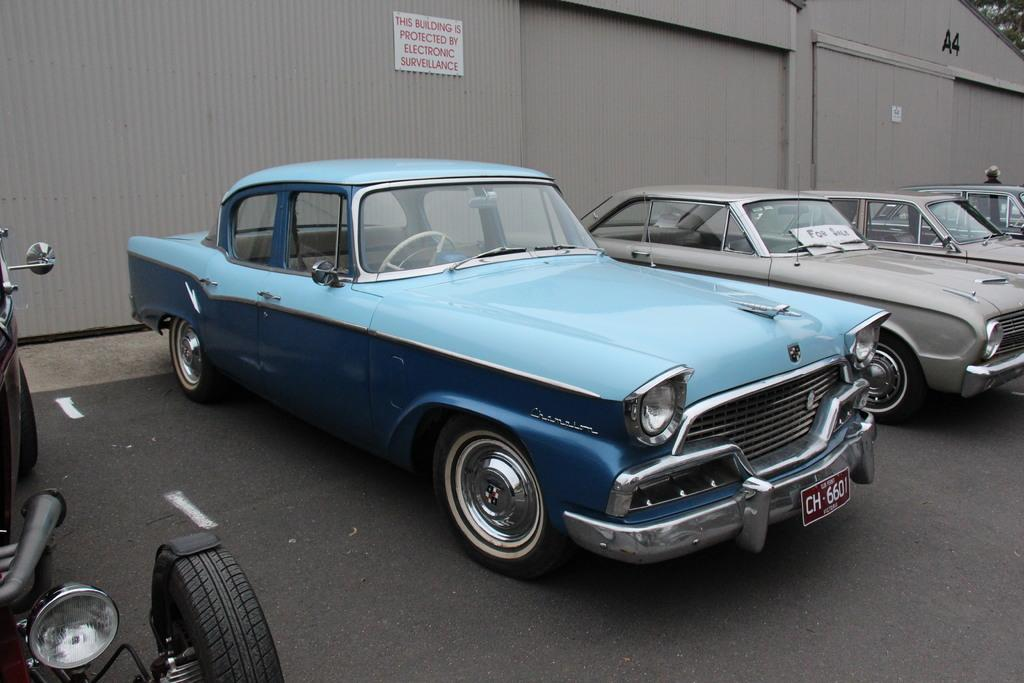What can be seen on the road in the image? There are vehicles on the road in the image. What is visible in the background of the image? There are boards on a shed in the background of the image. Where is the bucket located in the image? There is no bucket present in the image. What color are the eyes of the person in the image? There are no people or eyes visible in the image. 